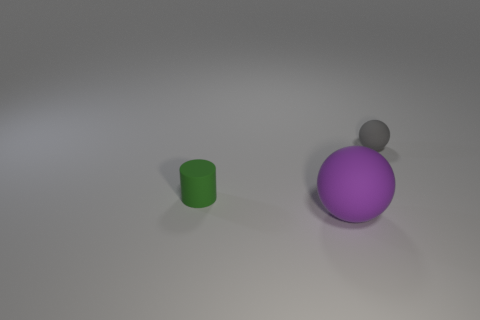Add 1 red cylinders. How many objects exist? 4 Subtract all purple balls. How many balls are left? 1 Subtract 0 yellow blocks. How many objects are left? 3 Subtract all spheres. How many objects are left? 1 Subtract 1 spheres. How many spheres are left? 1 Subtract all red cylinders. Subtract all red blocks. How many cylinders are left? 1 Subtract all green cylinders. Subtract all small green matte cylinders. How many objects are left? 1 Add 3 purple things. How many purple things are left? 4 Add 2 big things. How many big things exist? 3 